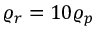<formula> <loc_0><loc_0><loc_500><loc_500>\varrho _ { r } = 1 0 \varrho _ { p }</formula> 